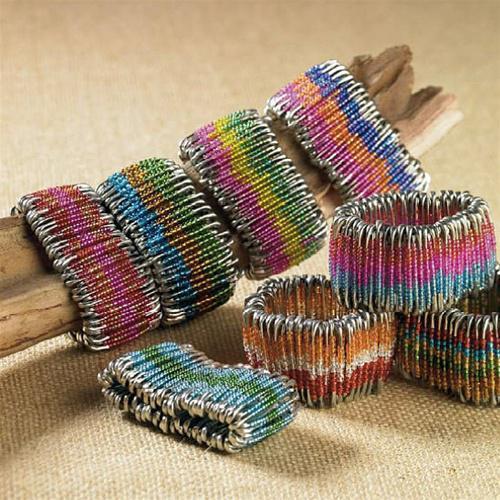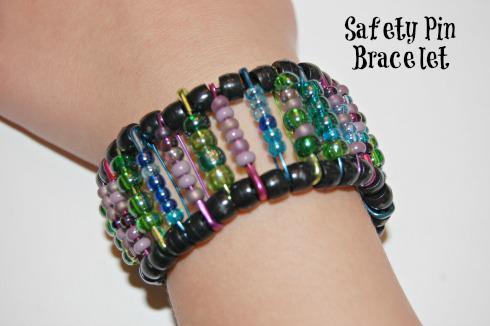The first image is the image on the left, the second image is the image on the right. Assess this claim about the two images: "In the right image, the bracelet is shown on a wrist.". Correct or not? Answer yes or no. Yes. The first image is the image on the left, the second image is the image on the right. Considering the images on both sides, is "there is an arm in the image on the right." valid? Answer yes or no. Yes. 